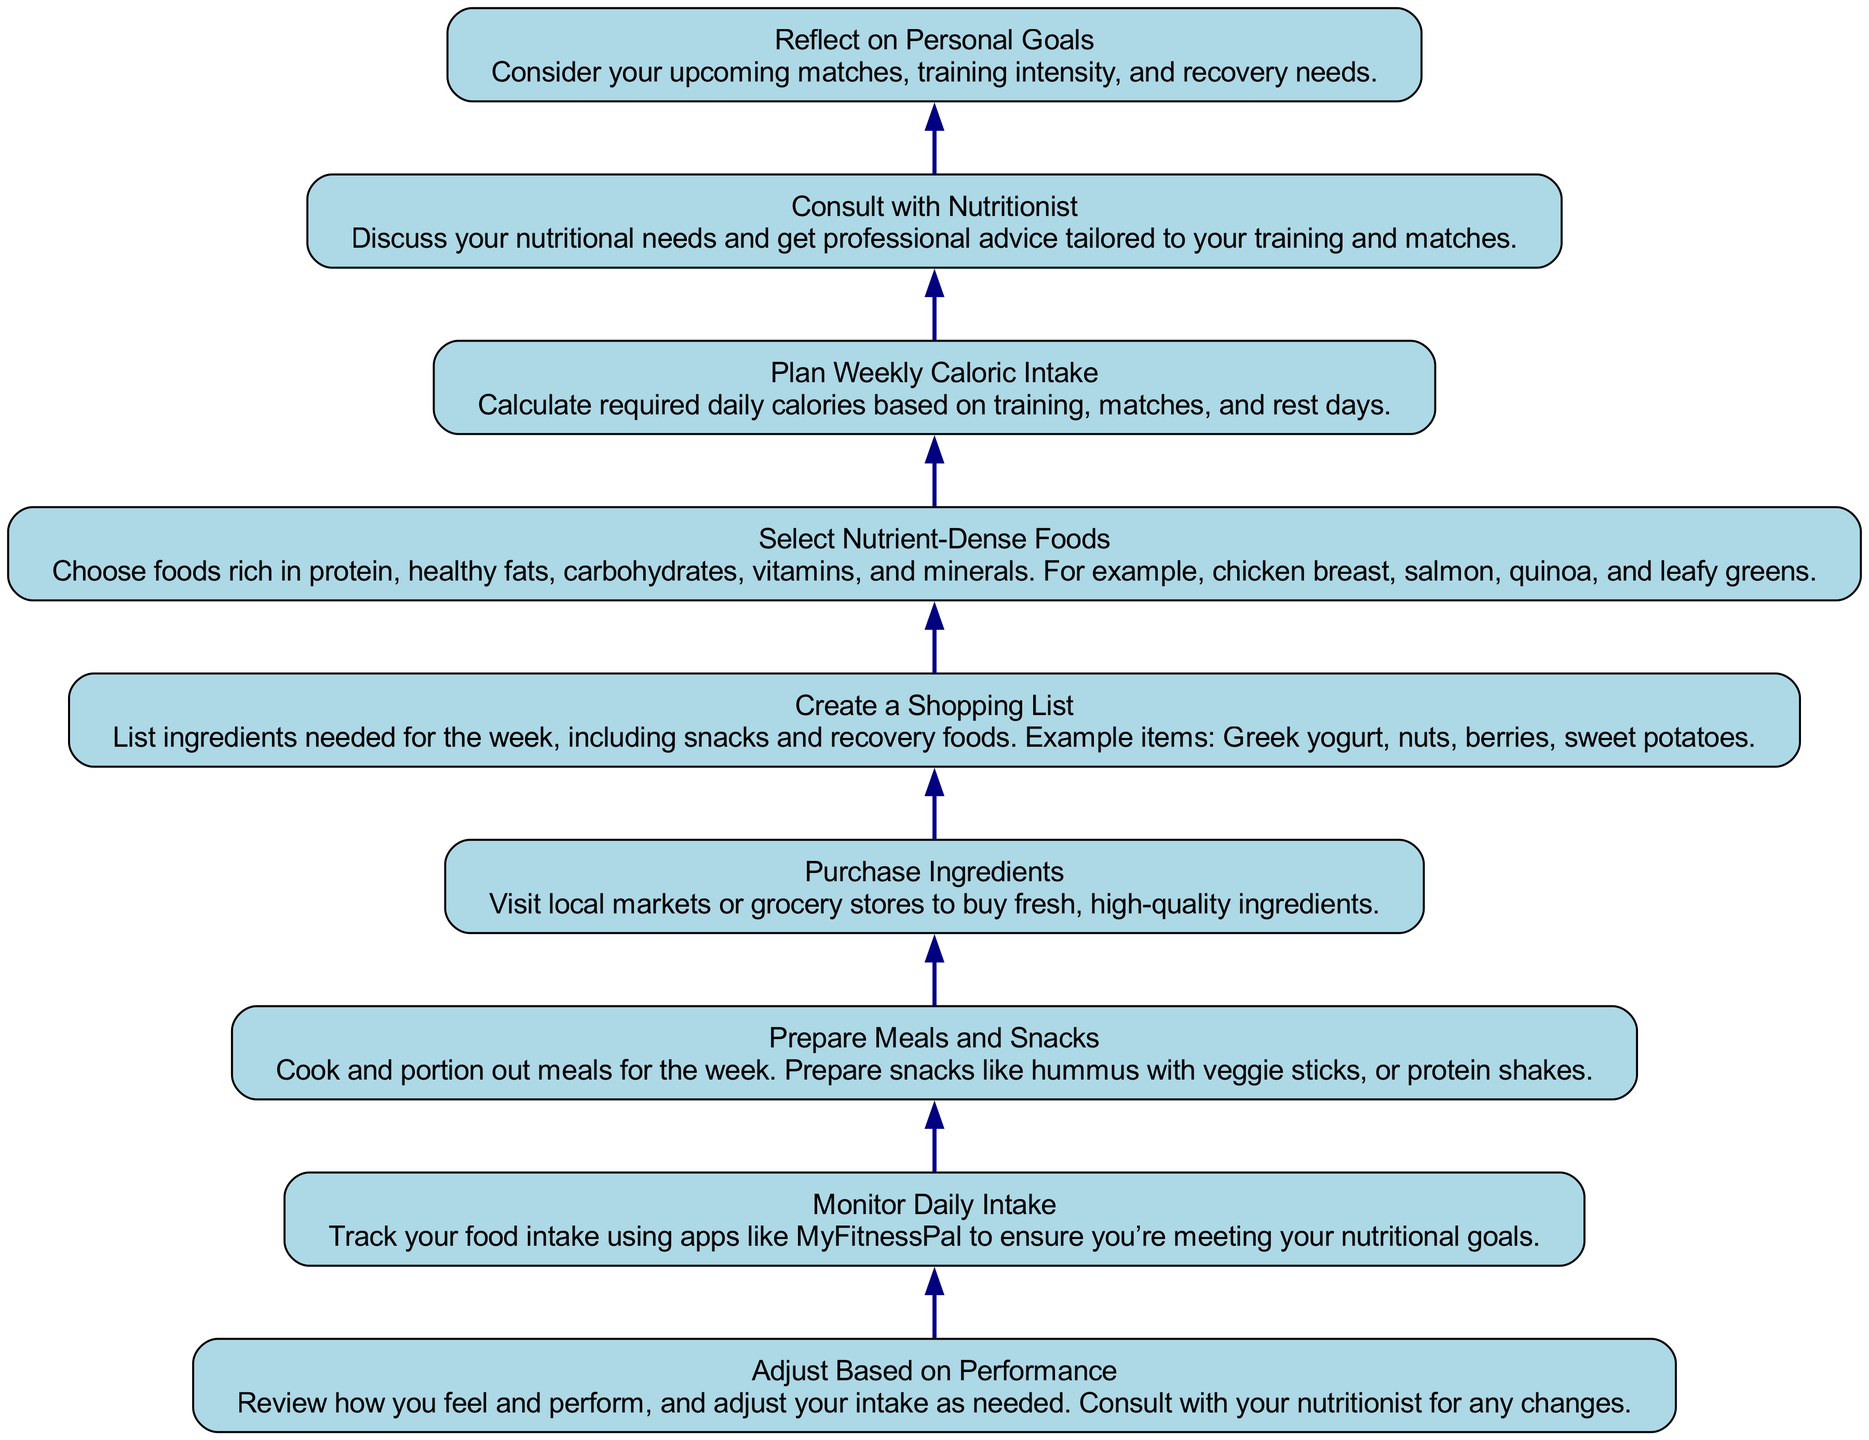What is the first step in the weekly nutrition plan? The diagram shows the first step at the bottom, which is "Reflect on Personal Goals." This indicates that assessing your personal goals is the foundational step before moving on to other tasks.
Answer: Reflect on Personal Goals How many nodes are in the diagram? By counting each of the steps listed in the diagram, there are a total of nine distinct nodes that represent different stages in the nutrition plan.
Answer: Nine What is the last action to be taken in the weekly nutrition plan? The last action indicated at the top of the diagram is "Adjust Based on Performance." This means after monitoring the intake, adjustments should be made accordingly.
Answer: Adjust Based on Performance Which step comes immediately after purchasing ingredients? The diagram shows that after "Purchase Ingredients," the next step flowing upwards is "Prepare Meals and Snacks." This indicates a sequence in meal preparation after gathering supplies.
Answer: Prepare Meals and Snacks How does consulting with a nutritionist impact the weekly calories plan? The diagram indicates that "Consult with Nutritionist" must be performed before "Plan Weekly Caloric Intake." This means that obtaining professional advice is necessary for accurately calculating caloric needs based on personal training and competition.
Answer: It informs caloric intake What should be included in the shopping list? The diagram mentions that the "Create a Shopping List" step includes ingredients for the week, such as snacks and recovery foods. This highlights the importance of not just main meals but also appropriate snacks.
Answer: Snacks and recovery foods If an athlete feels fatigued, which step might they need to revisit? The flow suggests that if performance isn't optimal, particularly after "Monitor Daily Intake," they should go back to "Adjust Based on Performance" to make necessary dietary changes, possibly considering feedback from the nutritionist.
Answer: Adjust Based on Performance What category of foods must be selected in step four? Step four of the diagram requires selecting "Nutrient-Dense Foods," emphasizing the importance of foods rich in key nutrients essential for athletic performance and recovery.
Answer: Nutrient-Dense Foods What action should be taken before cooking meals? The diagram outlines that "Prepare Meals and Snacks" follows the purchasing of ingredients. Therefore, one must ensure that all items have been bought before commencing meal preparation.
Answer: Purchase Ingredients 